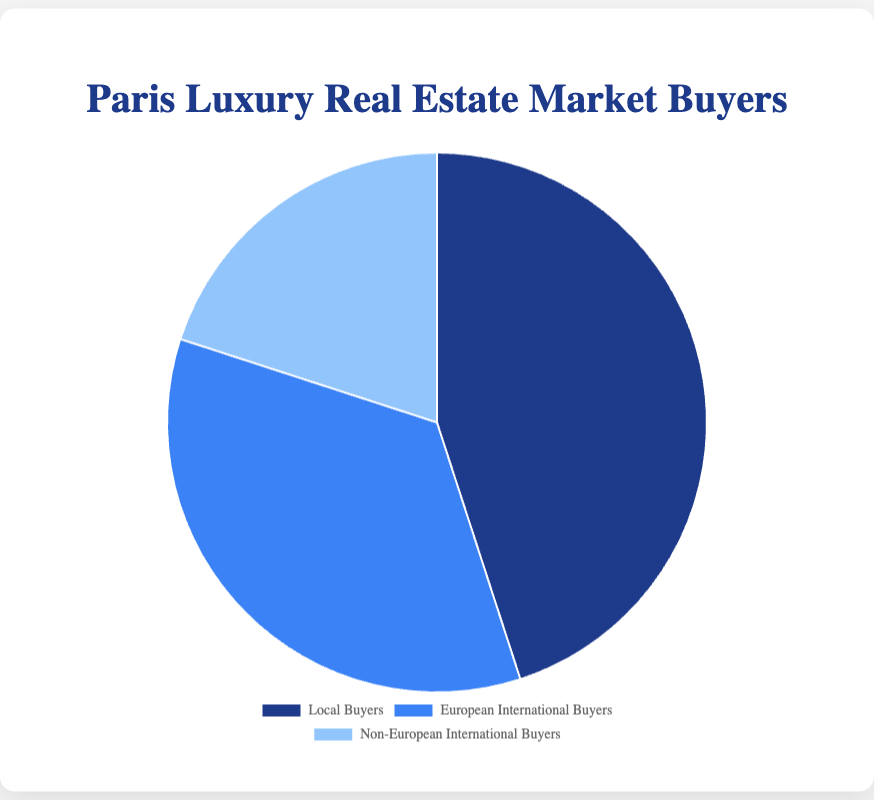Which group of buyers constitutes the largest proportion? By examining the proportions, Local Buyers have 45%, European International Buyers have 35%, and Non-European International Buyers have 20%. Local Buyers' 45% is the largest.
Answer: Local Buyers Which group has the smallest proportion of buyers? Comparing the sizes of the slices, Non-European International Buyers have the smallest proportion at 20%.
Answer: Non-European International Buyers What is the combined percentage of international buyers (both European and Non-European)? Add the percentages of European International Buyers (35%) and Non-European International Buyers (20%), which equals 55%.
Answer: 55% Are local buyers more or less than half of the total buyers? Local Buyers are 45% of the total, which is less than half of 100%.
Answer: Less How much larger is the proportion of Local Buyers compared to Non-European International Buyers? Subtract the percentage of Non-European International Buyers (20%) from Local Buyers (45%), resulting in a 25% difference.
Answer: 25% If there were 2000 total transactions, how many were made by European International Buyers? Calculate 35% of 2000. 0.35 * 2000 = 700. Thus, 700 transactions were made by European International Buyers.
Answer: 700 What fraction of the pie chart do European and Non-European International Buyers collectively represent? Sum their percentages: European International Buyers (35%) + Non-European International Buyers (20%) = 55%. Thus, they represent 55% of the pie chart.
Answer: 55% What is the ratio of Local Buyers to European International Buyers? The ratio of Local Buyers (45%) to European International Buyers (35%) is 45:35, which simplifies to 9:7.
Answer: 9:7 What is the visual color associated with Non-European International Buyers? By reviewing the color scheme, Non-European International Buyers are represented by a light blue color.
Answer: Light blue If European International Buyers increased by 10%, what would be their new proportion? Adding 10% to European International Buyers' current 35% gives 45%.
Answer: 45% 